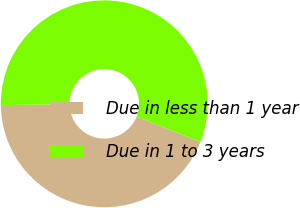Convert chart. <chart><loc_0><loc_0><loc_500><loc_500><pie_chart><fcel>Due in less than 1 year<fcel>Due in 1 to 3 years<nl><fcel>43.79%<fcel>56.21%<nl></chart> 